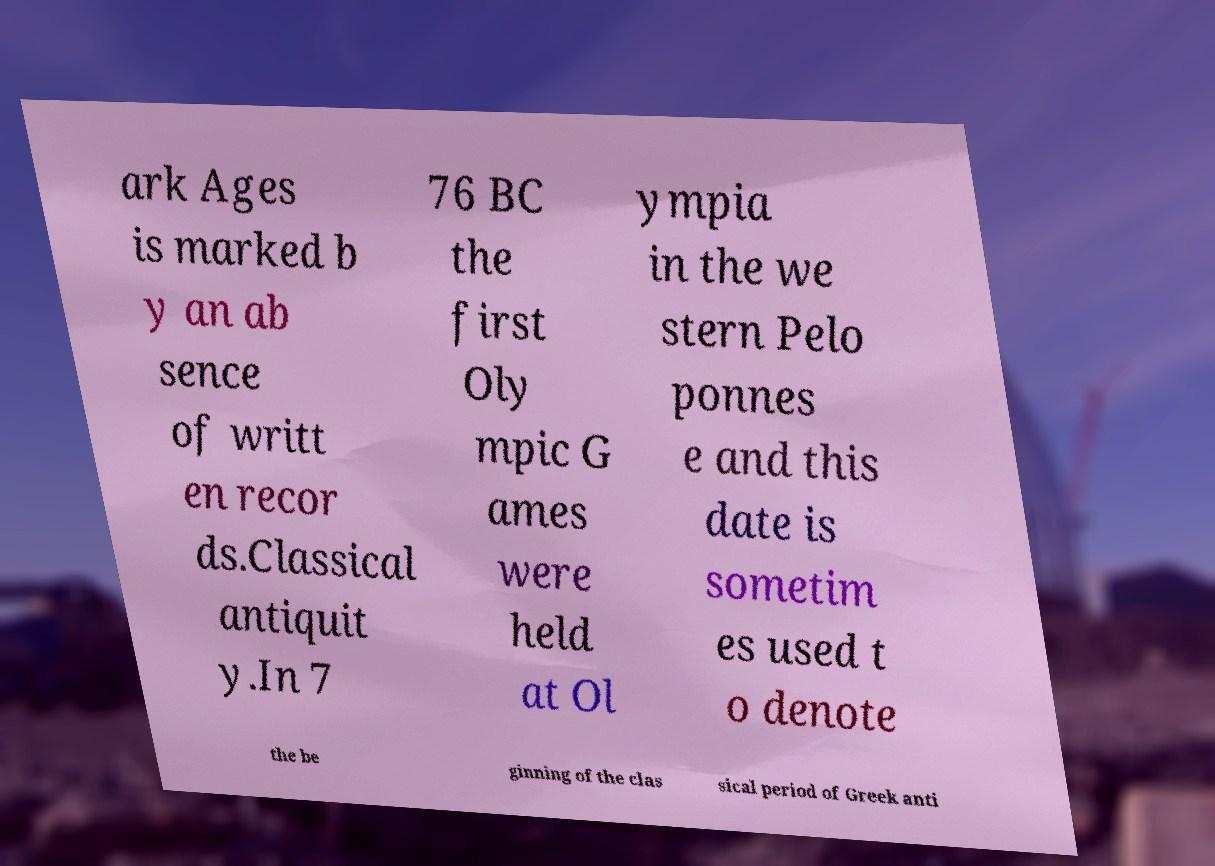There's text embedded in this image that I need extracted. Can you transcribe it verbatim? ark Ages is marked b y an ab sence of writt en recor ds.Classical antiquit y.In 7 76 BC the first Oly mpic G ames were held at Ol ympia in the we stern Pelo ponnes e and this date is sometim es used t o denote the be ginning of the clas sical period of Greek anti 